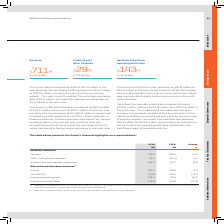According to Sophos Group's financial document, What are the values for FY18 restated for? Restated for the adoption of IFRS 15 and change in accounting policy in respect of research and development expenditure tax credit scheme and provision for interest on uncertain tax positions, as explained in note 2 of the Financial Statements. The document states: "1 Restated for the adoption of IFRS 15 and change in accounting policy in respect of research and development expenditure tax credit scheme and provis..." Also, Where can the definitions and reconciliations for non-GAAP measures under alternative performance measures be found? in note 5 of the Financial Statements. The document states: "reconciliations of non-GAAP measures are included in note 5 of the Financial Statements..." Also, What are the components under Statutory measures in the table? The document contains multiple relevant values: Revenue, Profit / (Loss) before taxation, Net cash flow from operating activities. From the document: "Net cash flow from operating activities 142.9 147.7 (3.2) Revenue 710.6 639.0 11.2 Profit / (Loss) before taxation 53.6 (41.0) nm..." Additionally, In which year was Billings larger? According to the financial document, FY18. The relevant text states: "(FY18: $639M)..." Also, can you calculate: What was the change in Revenue in 2019 from 2018? Based on the calculation: 710.6-639.0, the result is 71.6 (in millions). This is based on the information: "Revenue 710.6 639.0 11.2 Revenue 710.6 639.0 11.2..." The key data points involved are: 639.0, 710.6. Also, can you calculate: What was the average revenue in 2018 and 2019? To answer this question, I need to perform calculations using the financial data. The calculation is: (710.6+639.0)/2, which equals 674.8 (in millions). This is based on the information: "Revenue 710.6 639.0 11.2 Revenue 710.6 639.0 11.2..." The key data points involved are: 639.0, 710.6. 